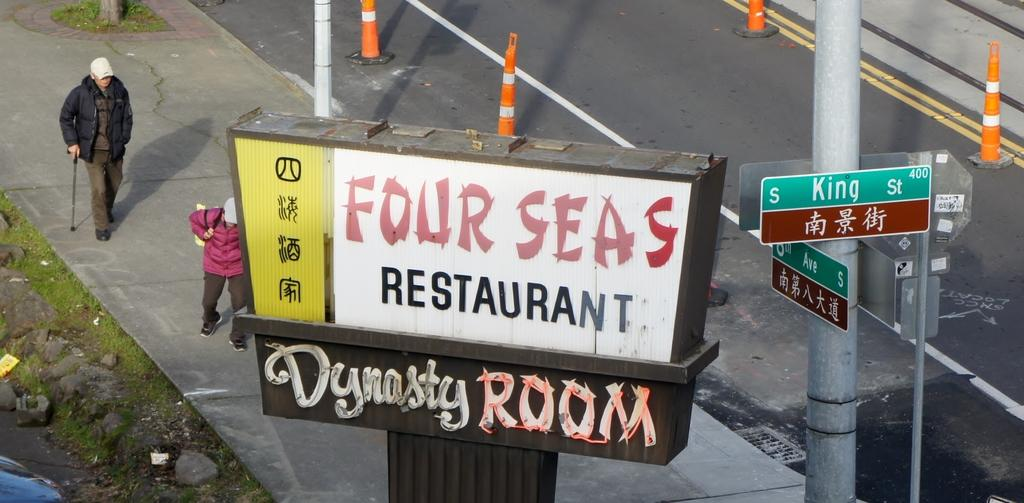Provide a one-sentence caption for the provided image. Pedestrians walk below a sign for the Four Seas restaurant. 